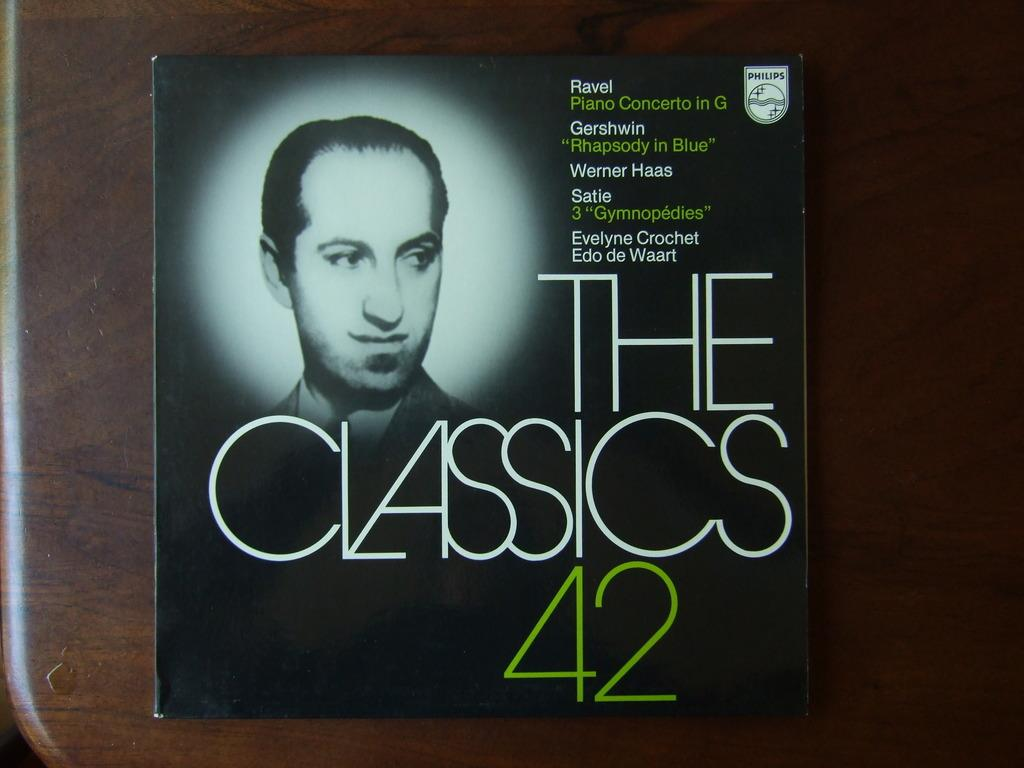What object is present on the wooden plank in the image? There is a book on the wooden plank in the image. What can be said about the appearance of the book? The book is black in color. What is written on the book? "The Classics 42" is written on the book. What is depicted on the book? There is a man's picture on the book. What type of cake is being served at the event in the image? There is no event or cake present in the image; it features a wooden plank with a black book on it. How many tickets are visible in the image? There are no tickets present in the image. 